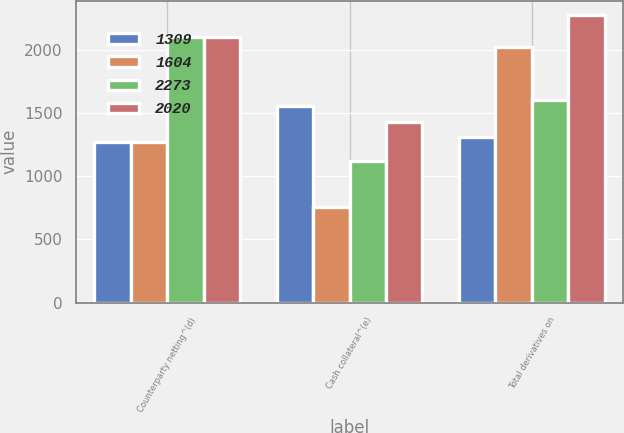Convert chart to OTSL. <chart><loc_0><loc_0><loc_500><loc_500><stacked_bar_chart><ecel><fcel>Counterparty netting^(d)<fcel>Cash collateral^(e)<fcel>Total derivatives on<nl><fcel>1309<fcel>1268<fcel>1554<fcel>1309<nl><fcel>1604<fcel>1268<fcel>760<fcel>2020<nl><fcel>2273<fcel>2102<fcel>1119<fcel>1604<nl><fcel>2020<fcel>2102<fcel>1429<fcel>2273<nl></chart> 